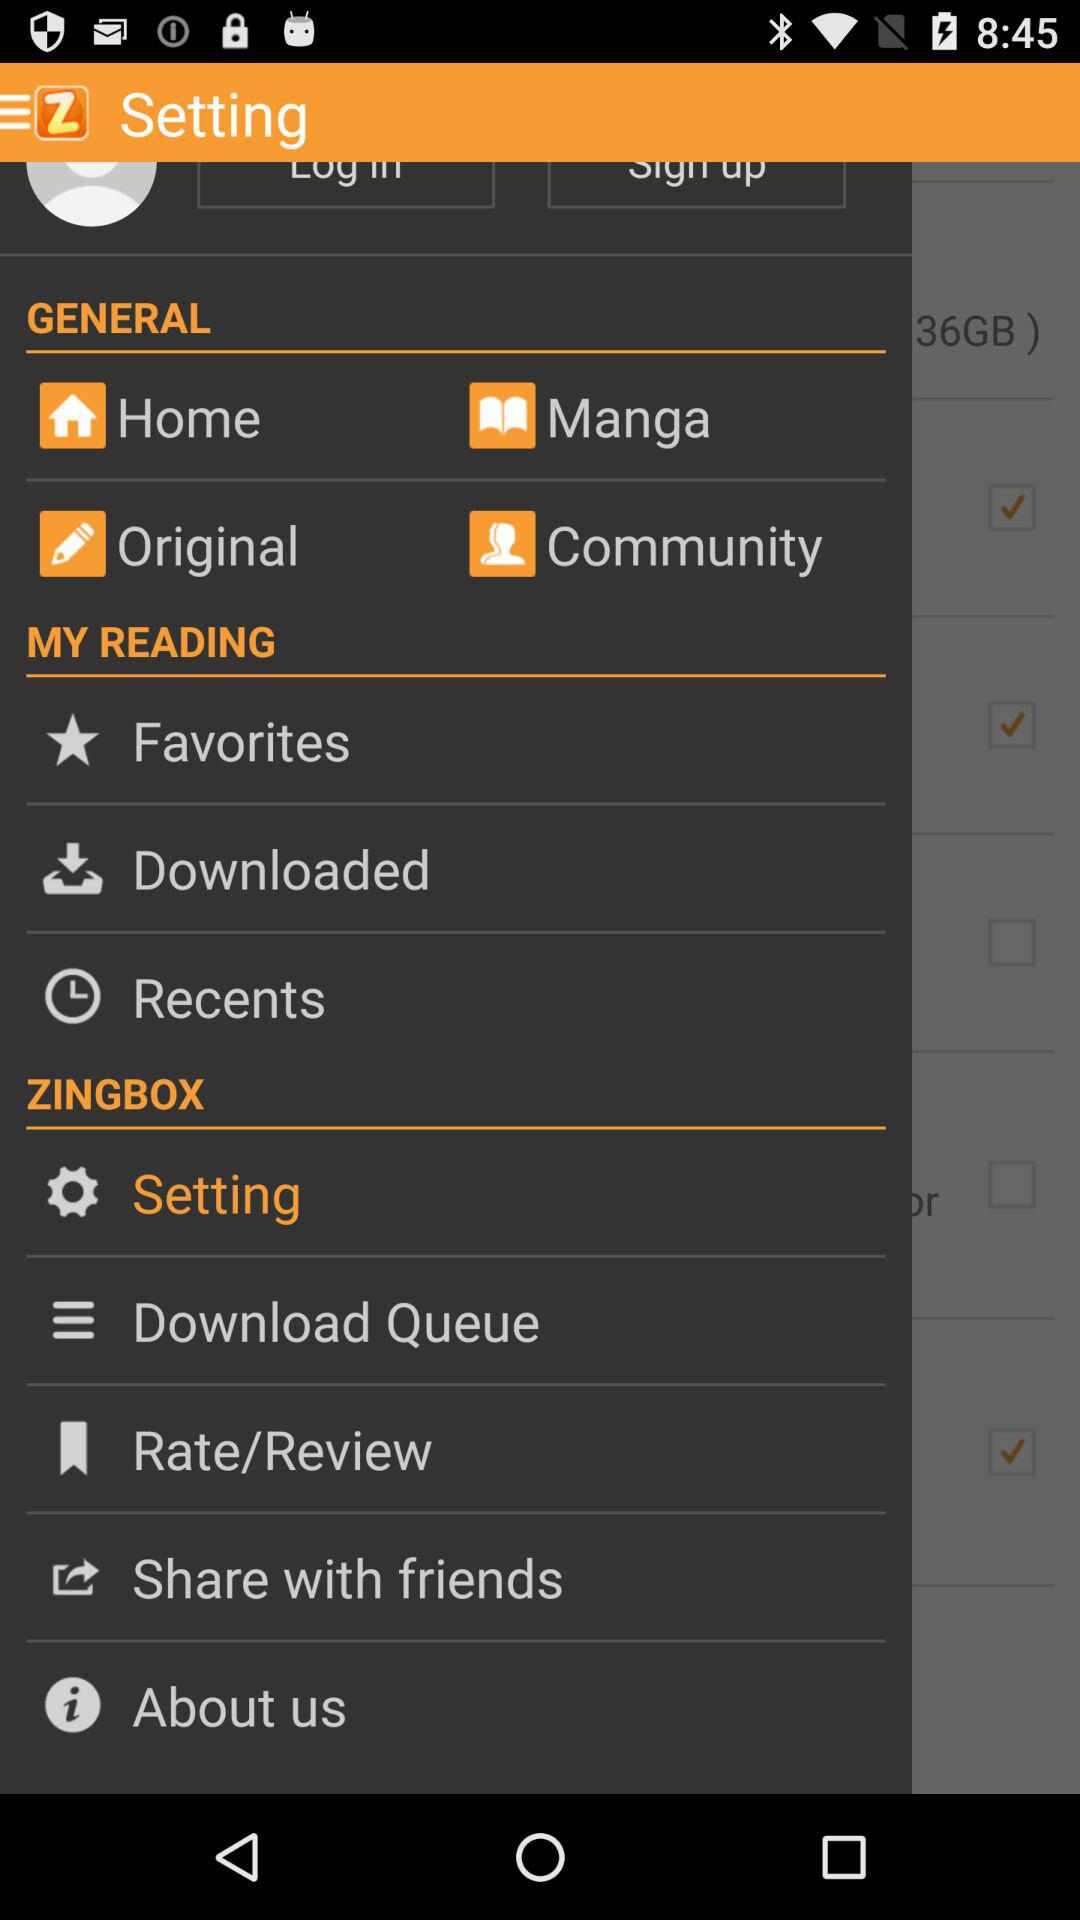Which option is selected? The selected option is Setting. 